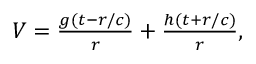Convert formula to latex. <formula><loc_0><loc_0><loc_500><loc_500>\begin{array} { r } { V = \frac { g ( t - r / c ) } { r } + \frac { h ( t + r / c ) } { r } , } \end{array}</formula> 